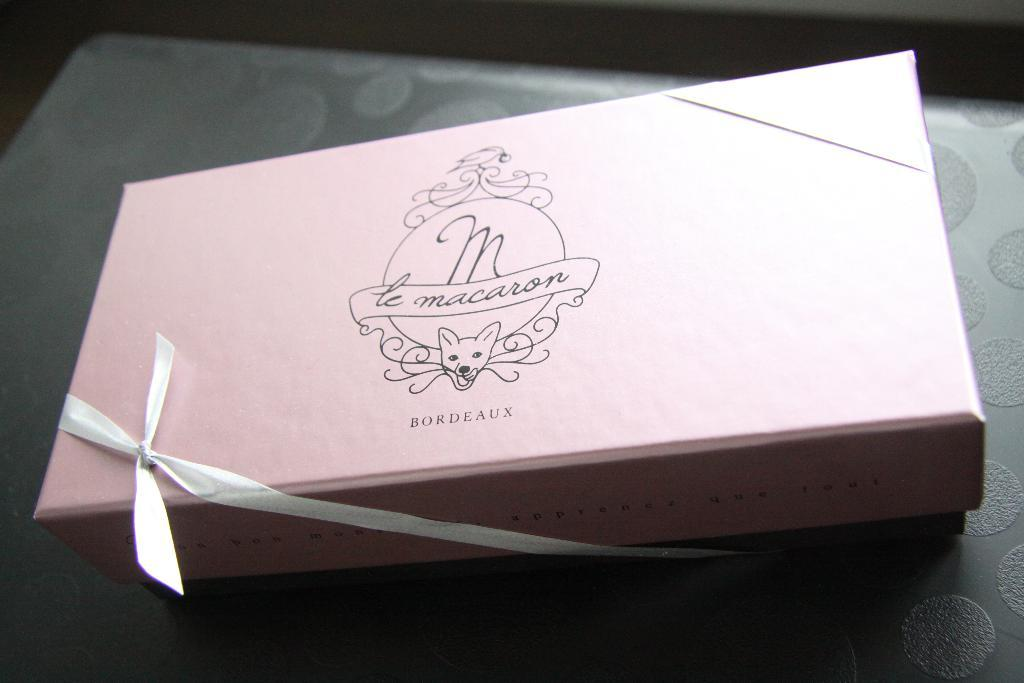<image>
Offer a succinct explanation of the picture presented. A gifted packaged of maracon bordeaux is placed on the table. 